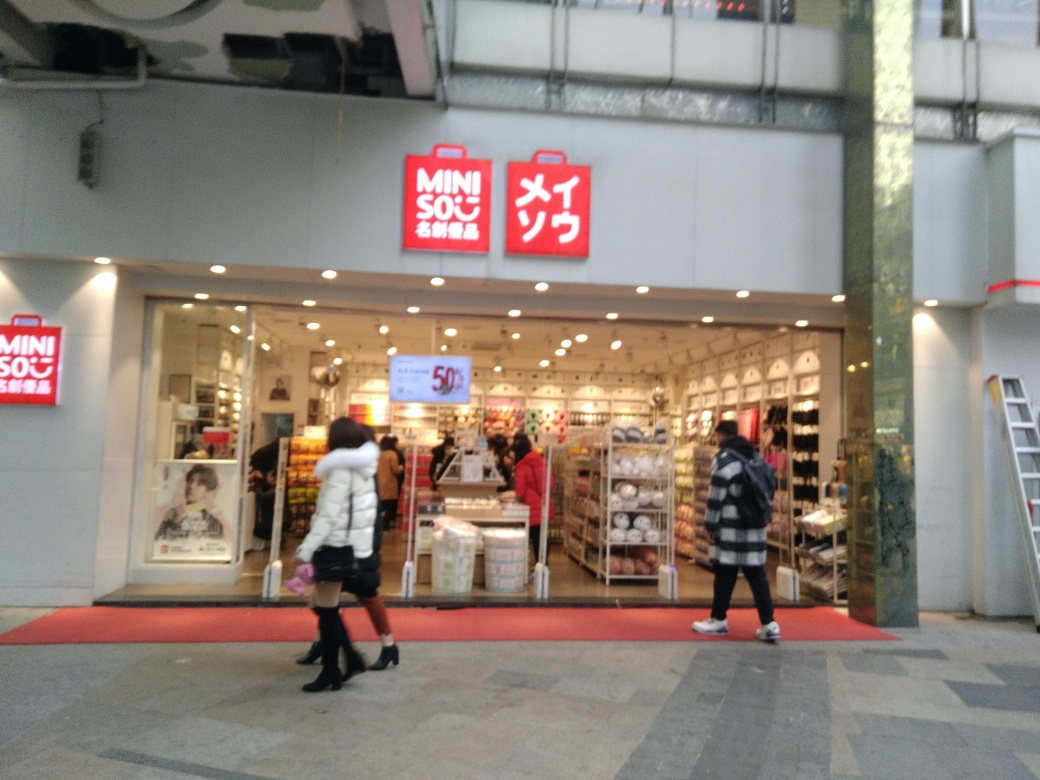How clear is the text on the storefront?
A. Clear and distinguishable
B. Partially obscured
C. Blurry and illegible
Answer with the option's letter from the given choices directly.
 A. 